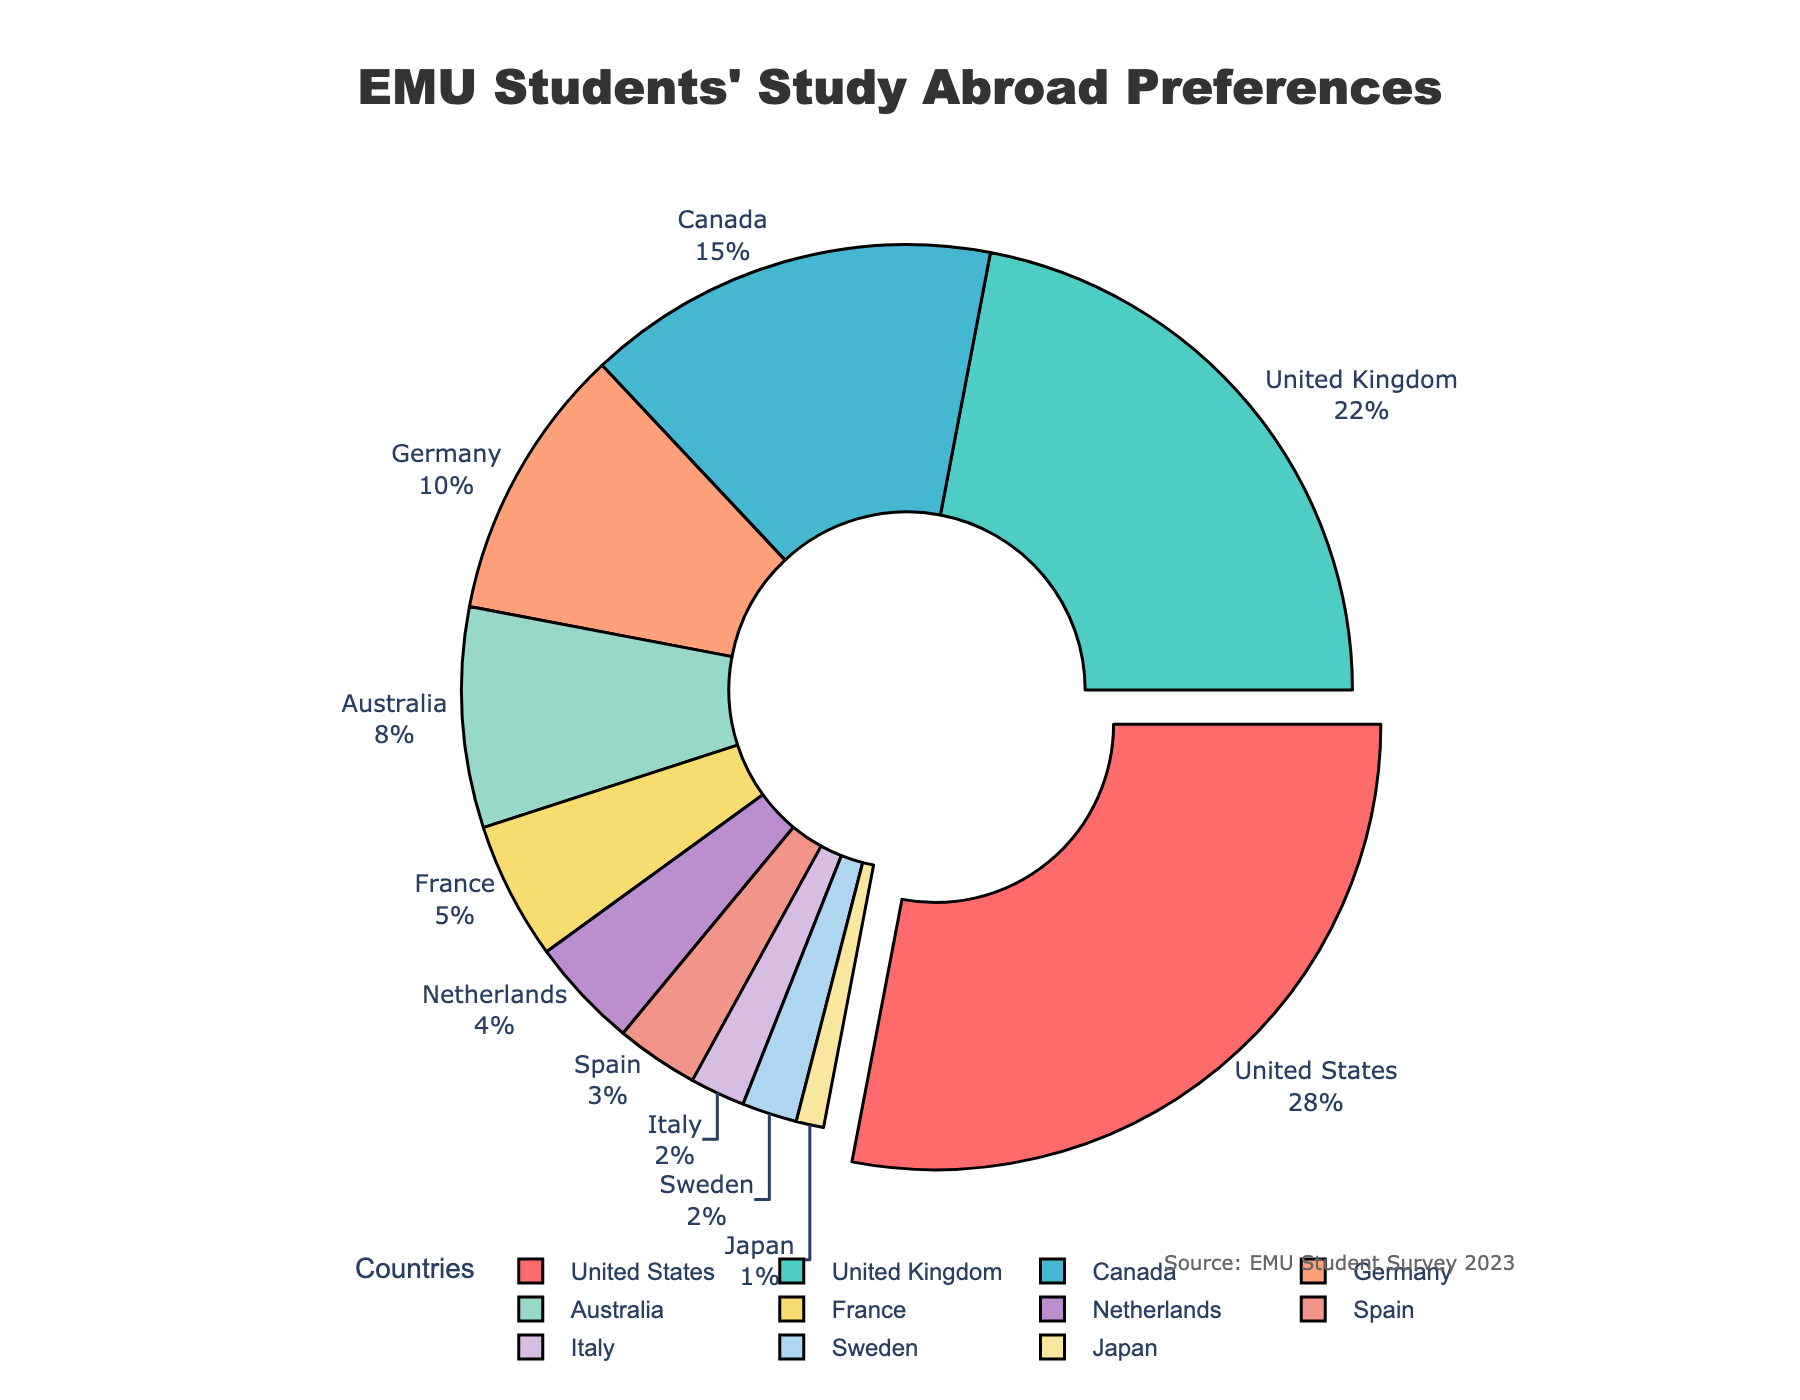What's the most preferred study abroad destination among EMU students? The pie chart shows the distribution of preferences where the largest section represents the most preferred destination. The United States holds the biggest portion at 28%.
Answer: The United States Which two countries combined have the same preference percentage as Germany? Germany has 10%, and looking for smaller sections summing up to 10%, we find France (5%) and the Netherlands (4%) total 9%, but Sweden (2%) and Italy (2%) sum to 4%, close but not 10%. Spain (3%) and Italy (2%) sum to 5%, still not 10%. France (5%) and Sweden (2%) sum to 7%, remaining partial combinations do not match. Thus, none exactly.
Answer: None What is the preference difference between the United States and the United Kingdom? The United States has 28% and the United Kingdom has 22% preferences. The difference is calculated as 28% - 22%.
Answer: 6% Which country has the smallest percentage of preference as a study abroad destination? The smallest section in the pie chart indicates the least preferred country, Japan, with 1%.
Answer: Japan How many countries have a preference percentage greater than 5%? By looking at the pie chart, countries with preference percentages above 5% are United States (28%), United Kingdom (22%), Canada (15%), Germany (10%), and Australia (8%). Thus, there are 5 countries.
Answer: 5 What combined percentage of preferences do Canada, Germany, and Australia represent? Canada has 15%, Germany has 10%, and Australia has 8%. Adding them together gives 15% + 10% + 8% = 33%.
Answer: 33% Which country is represented by the red section in the pie chart? The red section specifically represents the country with the largest preference, which is the United States according to the color coding of the pie.
Answer: The United States Are there more students preferring the Netherlands or Spain as their study abroad destination? According to the pie chart, the Netherlands has 4% preference while Spain has 3%. Therefore, more students prefer the Netherlands over Spain.
Answer: The Netherlands What is the average preference percentage for Australia, France, and Netherlands? The percentages for Australia (8%), France (5%), and Netherlands (4%) are noted. The average is calculated as (8% + 5% + 4%) / 3 = 17% / 3 ≈ 5.67%.
Answer: 5.67% Which country has a preference percentage that is half of Canada's? Canada's preference is 15%. Half of this amount is 15% / 2 = 7.5%. No country has exactly 7.5%, but Australia has a close percentage at 8%.
Answer: Australia 